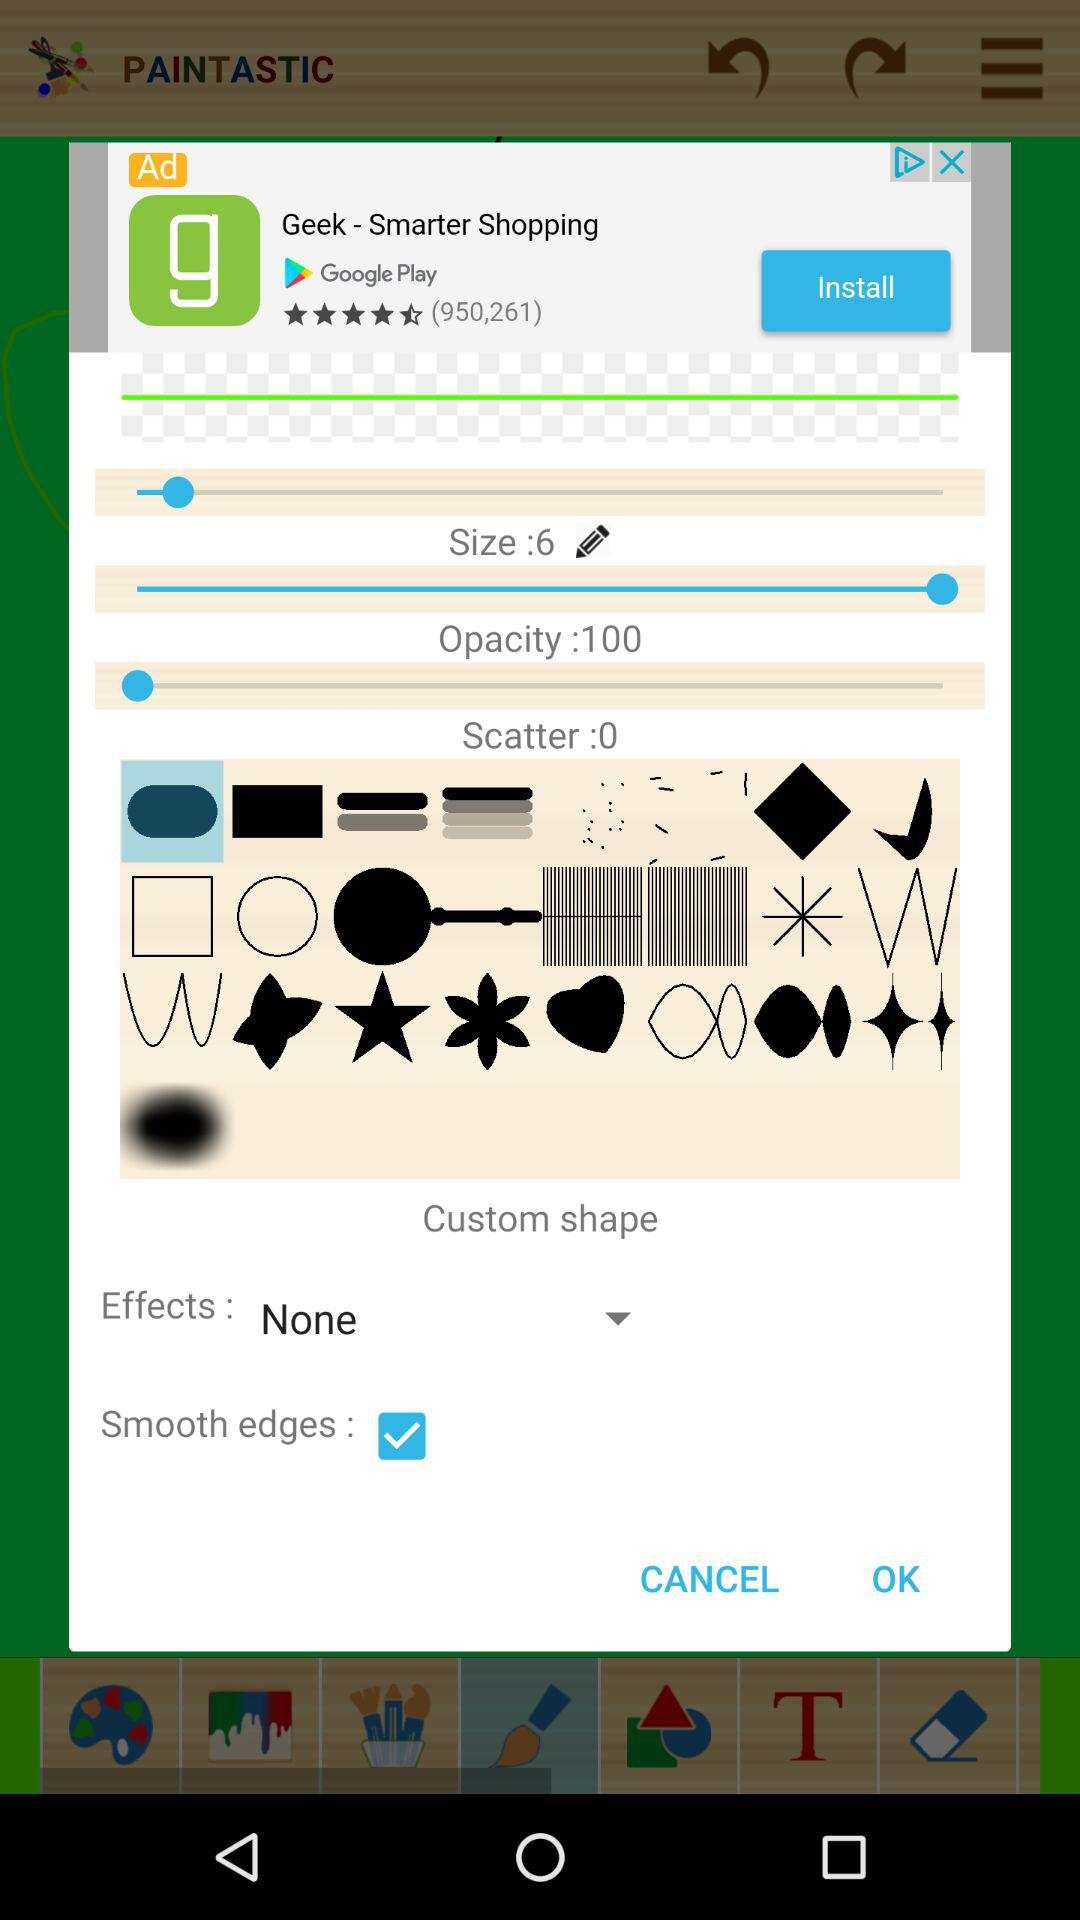What is the setting for effects? The setting for effects is "None". 